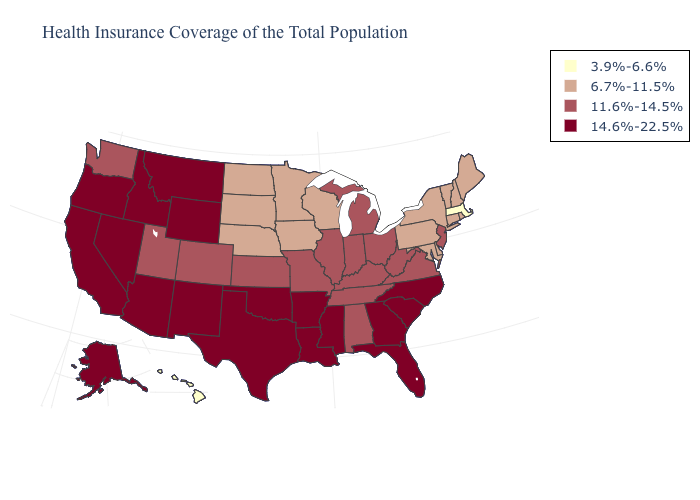Among the states that border Oklahoma , does Colorado have the lowest value?
Short answer required. Yes. Name the states that have a value in the range 6.7%-11.5%?
Give a very brief answer. Connecticut, Delaware, Iowa, Maine, Maryland, Minnesota, Nebraska, New Hampshire, New York, North Dakota, Pennsylvania, Rhode Island, South Dakota, Vermont, Wisconsin. Name the states that have a value in the range 14.6%-22.5%?
Concise answer only. Alaska, Arizona, Arkansas, California, Florida, Georgia, Idaho, Louisiana, Mississippi, Montana, Nevada, New Mexico, North Carolina, Oklahoma, Oregon, South Carolina, Texas, Wyoming. Does Hawaii have the lowest value in the USA?
Give a very brief answer. Yes. Name the states that have a value in the range 6.7%-11.5%?
Write a very short answer. Connecticut, Delaware, Iowa, Maine, Maryland, Minnesota, Nebraska, New Hampshire, New York, North Dakota, Pennsylvania, Rhode Island, South Dakota, Vermont, Wisconsin. Is the legend a continuous bar?
Be succinct. No. Name the states that have a value in the range 6.7%-11.5%?
Be succinct. Connecticut, Delaware, Iowa, Maine, Maryland, Minnesota, Nebraska, New Hampshire, New York, North Dakota, Pennsylvania, Rhode Island, South Dakota, Vermont, Wisconsin. What is the value of Montana?
Write a very short answer. 14.6%-22.5%. What is the highest value in the West ?
Quick response, please. 14.6%-22.5%. What is the value of West Virginia?
Quick response, please. 11.6%-14.5%. Among the states that border Georgia , does Florida have the highest value?
Be succinct. Yes. What is the lowest value in the South?
Be succinct. 6.7%-11.5%. Name the states that have a value in the range 14.6%-22.5%?
Answer briefly. Alaska, Arizona, Arkansas, California, Florida, Georgia, Idaho, Louisiana, Mississippi, Montana, Nevada, New Mexico, North Carolina, Oklahoma, Oregon, South Carolina, Texas, Wyoming. 